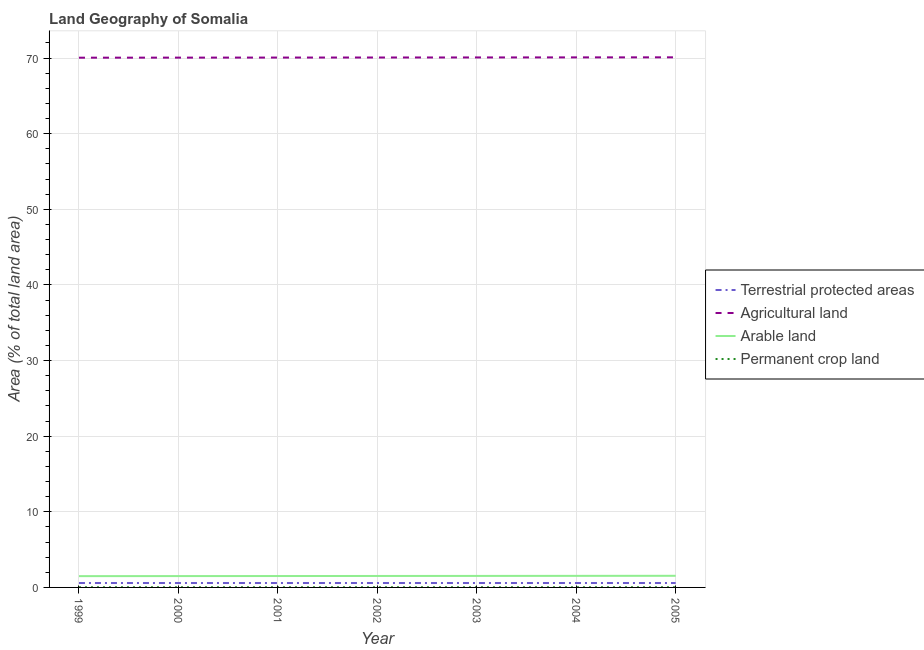Does the line corresponding to percentage of area under agricultural land intersect with the line corresponding to percentage of area under permanent crop land?
Your response must be concise. No. Is the number of lines equal to the number of legend labels?
Offer a terse response. Yes. What is the percentage of land under terrestrial protection in 2001?
Your response must be concise. 0.58. Across all years, what is the maximum percentage of area under permanent crop land?
Your answer should be compact. 0.02. Across all years, what is the minimum percentage of area under agricultural land?
Ensure brevity in your answer.  70.06. What is the total percentage of area under arable land in the graph?
Offer a very short reply. 10.61. What is the difference between the percentage of area under permanent crop land in 2001 and that in 2005?
Provide a short and direct response. -0. What is the difference between the percentage of area under agricultural land in 2002 and the percentage of land under terrestrial protection in 2003?
Provide a succinct answer. 69.5. What is the average percentage of area under permanent crop land per year?
Keep it short and to the point. 0.02. In the year 2005, what is the difference between the percentage of area under arable land and percentage of area under agricultural land?
Provide a succinct answer. -68.57. What is the ratio of the percentage of area under agricultural land in 2001 to that in 2005?
Ensure brevity in your answer.  1. Is the percentage of land under terrestrial protection in 1999 less than that in 2005?
Provide a short and direct response. No. What is the difference between the highest and the second highest percentage of area under agricultural land?
Your answer should be very brief. 0.01. What is the difference between the highest and the lowest percentage of land under terrestrial protection?
Your response must be concise. 3.1765633260461e-6. Is it the case that in every year, the sum of the percentage of area under arable land and percentage of area under permanent crop land is greater than the sum of percentage of land under terrestrial protection and percentage of area under agricultural land?
Your response must be concise. Yes. Is it the case that in every year, the sum of the percentage of land under terrestrial protection and percentage of area under agricultural land is greater than the percentage of area under arable land?
Provide a succinct answer. Yes. Does the percentage of area under arable land monotonically increase over the years?
Make the answer very short. Yes. Is the percentage of area under agricultural land strictly less than the percentage of area under permanent crop land over the years?
Ensure brevity in your answer.  No. How many years are there in the graph?
Provide a short and direct response. 7. What is the difference between two consecutive major ticks on the Y-axis?
Provide a short and direct response. 10. Are the values on the major ticks of Y-axis written in scientific E-notation?
Give a very brief answer. No. Does the graph contain grids?
Your response must be concise. Yes. Where does the legend appear in the graph?
Offer a terse response. Center right. What is the title of the graph?
Make the answer very short. Land Geography of Somalia. What is the label or title of the X-axis?
Offer a very short reply. Year. What is the label or title of the Y-axis?
Offer a terse response. Area (% of total land area). What is the Area (% of total land area) of Terrestrial protected areas in 1999?
Provide a succinct answer. 0.58. What is the Area (% of total land area) of Agricultural land in 1999?
Your answer should be very brief. 70.06. What is the Area (% of total land area) of Arable land in 1999?
Offer a very short reply. 1.49. What is the Area (% of total land area) of Permanent crop land in 1999?
Ensure brevity in your answer.  0.02. What is the Area (% of total land area) in Terrestrial protected areas in 2000?
Provide a succinct answer. 0.58. What is the Area (% of total land area) in Agricultural land in 2000?
Your answer should be very brief. 70.07. What is the Area (% of total land area) in Arable land in 2000?
Offer a terse response. 1.5. What is the Area (% of total land area) of Permanent crop land in 2000?
Make the answer very short. 0.02. What is the Area (% of total land area) of Terrestrial protected areas in 2001?
Keep it short and to the point. 0.58. What is the Area (% of total land area) in Agricultural land in 2001?
Give a very brief answer. 70.07. What is the Area (% of total land area) in Arable land in 2001?
Your answer should be very brief. 1.51. What is the Area (% of total land area) in Permanent crop land in 2001?
Give a very brief answer. 0.02. What is the Area (% of total land area) in Terrestrial protected areas in 2002?
Offer a very short reply. 0.58. What is the Area (% of total land area) in Agricultural land in 2002?
Your answer should be compact. 70.08. What is the Area (% of total land area) in Arable land in 2002?
Ensure brevity in your answer.  1.52. What is the Area (% of total land area) in Permanent crop land in 2002?
Your answer should be compact. 0.02. What is the Area (% of total land area) of Terrestrial protected areas in 2003?
Offer a terse response. 0.58. What is the Area (% of total land area) in Agricultural land in 2003?
Ensure brevity in your answer.  70.09. What is the Area (% of total land area) in Arable land in 2003?
Your answer should be very brief. 1.52. What is the Area (% of total land area) of Permanent crop land in 2003?
Your answer should be very brief. 0.02. What is the Area (% of total land area) of Terrestrial protected areas in 2004?
Ensure brevity in your answer.  0.58. What is the Area (% of total land area) of Agricultural land in 2004?
Offer a very short reply. 70.1. What is the Area (% of total land area) in Arable land in 2004?
Offer a terse response. 1.53. What is the Area (% of total land area) in Permanent crop land in 2004?
Offer a terse response. 0.02. What is the Area (% of total land area) in Terrestrial protected areas in 2005?
Provide a short and direct response. 0.58. What is the Area (% of total land area) of Agricultural land in 2005?
Provide a succinct answer. 70.11. What is the Area (% of total land area) in Arable land in 2005?
Make the answer very short. 1.54. What is the Area (% of total land area) of Permanent crop land in 2005?
Offer a terse response. 0.02. Across all years, what is the maximum Area (% of total land area) in Terrestrial protected areas?
Provide a succinct answer. 0.58. Across all years, what is the maximum Area (% of total land area) in Agricultural land?
Provide a succinct answer. 70.11. Across all years, what is the maximum Area (% of total land area) in Arable land?
Provide a short and direct response. 1.54. Across all years, what is the maximum Area (% of total land area) in Permanent crop land?
Your response must be concise. 0.02. Across all years, what is the minimum Area (% of total land area) of Terrestrial protected areas?
Offer a very short reply. 0.58. Across all years, what is the minimum Area (% of total land area) of Agricultural land?
Offer a terse response. 70.06. Across all years, what is the minimum Area (% of total land area) of Arable land?
Give a very brief answer. 1.49. Across all years, what is the minimum Area (% of total land area) of Permanent crop land?
Offer a very short reply. 0.02. What is the total Area (% of total land area) of Terrestrial protected areas in the graph?
Your response must be concise. 4.09. What is the total Area (% of total land area) in Agricultural land in the graph?
Your answer should be compact. 490.57. What is the total Area (% of total land area) of Arable land in the graph?
Offer a terse response. 10.61. What is the total Area (% of total land area) in Permanent crop land in the graph?
Offer a terse response. 0.16. What is the difference between the Area (% of total land area) in Terrestrial protected areas in 1999 and that in 2000?
Your answer should be compact. -0. What is the difference between the Area (% of total land area) of Agricultural land in 1999 and that in 2000?
Provide a short and direct response. -0.01. What is the difference between the Area (% of total land area) of Arable land in 1999 and that in 2000?
Your answer should be compact. -0.01. What is the difference between the Area (% of total land area) of Terrestrial protected areas in 1999 and that in 2001?
Keep it short and to the point. 0. What is the difference between the Area (% of total land area) in Agricultural land in 1999 and that in 2001?
Make the answer very short. -0.02. What is the difference between the Area (% of total land area) in Arable land in 1999 and that in 2001?
Make the answer very short. -0.02. What is the difference between the Area (% of total land area) of Permanent crop land in 1999 and that in 2001?
Ensure brevity in your answer.  0. What is the difference between the Area (% of total land area) of Terrestrial protected areas in 1999 and that in 2002?
Make the answer very short. 0. What is the difference between the Area (% of total land area) in Agricultural land in 1999 and that in 2002?
Your answer should be very brief. -0.02. What is the difference between the Area (% of total land area) of Arable land in 1999 and that in 2002?
Your answer should be compact. -0.02. What is the difference between the Area (% of total land area) of Agricultural land in 1999 and that in 2003?
Keep it short and to the point. -0.03. What is the difference between the Area (% of total land area) of Arable land in 1999 and that in 2003?
Your answer should be very brief. -0.03. What is the difference between the Area (% of total land area) of Permanent crop land in 1999 and that in 2003?
Provide a short and direct response. -0. What is the difference between the Area (% of total land area) in Agricultural land in 1999 and that in 2004?
Provide a short and direct response. -0.04. What is the difference between the Area (% of total land area) in Arable land in 1999 and that in 2004?
Make the answer very short. -0.04. What is the difference between the Area (% of total land area) of Permanent crop land in 1999 and that in 2004?
Make the answer very short. -0. What is the difference between the Area (% of total land area) in Agricultural land in 1999 and that in 2005?
Offer a terse response. -0.05. What is the difference between the Area (% of total land area) of Arable land in 1999 and that in 2005?
Offer a very short reply. -0.05. What is the difference between the Area (% of total land area) of Permanent crop land in 1999 and that in 2005?
Ensure brevity in your answer.  -0. What is the difference between the Area (% of total land area) of Agricultural land in 2000 and that in 2001?
Offer a very short reply. -0.01. What is the difference between the Area (% of total land area) of Arable land in 2000 and that in 2001?
Make the answer very short. -0.01. What is the difference between the Area (% of total land area) of Permanent crop land in 2000 and that in 2001?
Offer a very short reply. 0. What is the difference between the Area (% of total land area) of Agricultural land in 2000 and that in 2002?
Keep it short and to the point. -0.02. What is the difference between the Area (% of total land area) of Arable land in 2000 and that in 2002?
Your response must be concise. -0.02. What is the difference between the Area (% of total land area) in Permanent crop land in 2000 and that in 2002?
Keep it short and to the point. 0. What is the difference between the Area (% of total land area) in Agricultural land in 2000 and that in 2003?
Your answer should be very brief. -0.02. What is the difference between the Area (% of total land area) of Arable land in 2000 and that in 2003?
Provide a short and direct response. -0.02. What is the difference between the Area (% of total land area) in Permanent crop land in 2000 and that in 2003?
Provide a succinct answer. -0. What is the difference between the Area (% of total land area) of Agricultural land in 2000 and that in 2004?
Offer a terse response. -0.03. What is the difference between the Area (% of total land area) in Arable land in 2000 and that in 2004?
Keep it short and to the point. -0.03. What is the difference between the Area (% of total land area) of Permanent crop land in 2000 and that in 2004?
Provide a short and direct response. -0. What is the difference between the Area (% of total land area) of Agricultural land in 2000 and that in 2005?
Your response must be concise. -0.04. What is the difference between the Area (% of total land area) of Arable land in 2000 and that in 2005?
Your answer should be compact. -0.04. What is the difference between the Area (% of total land area) of Permanent crop land in 2000 and that in 2005?
Offer a very short reply. -0. What is the difference between the Area (% of total land area) of Agricultural land in 2001 and that in 2002?
Your answer should be very brief. -0.01. What is the difference between the Area (% of total land area) of Arable land in 2001 and that in 2002?
Offer a very short reply. -0.01. What is the difference between the Area (% of total land area) in Permanent crop land in 2001 and that in 2002?
Keep it short and to the point. 0. What is the difference between the Area (% of total land area) in Agricultural land in 2001 and that in 2003?
Provide a succinct answer. -0.02. What is the difference between the Area (% of total land area) in Arable land in 2001 and that in 2003?
Your answer should be compact. -0.01. What is the difference between the Area (% of total land area) in Permanent crop land in 2001 and that in 2003?
Offer a very short reply. -0. What is the difference between the Area (% of total land area) of Agricultural land in 2001 and that in 2004?
Make the answer very short. -0.02. What is the difference between the Area (% of total land area) of Arable land in 2001 and that in 2004?
Your answer should be very brief. -0.02. What is the difference between the Area (% of total land area) in Permanent crop land in 2001 and that in 2004?
Your response must be concise. -0. What is the difference between the Area (% of total land area) of Agricultural land in 2001 and that in 2005?
Your answer should be compact. -0.03. What is the difference between the Area (% of total land area) of Arable land in 2001 and that in 2005?
Give a very brief answer. -0.03. What is the difference between the Area (% of total land area) of Permanent crop land in 2001 and that in 2005?
Your answer should be compact. -0. What is the difference between the Area (% of total land area) in Agricultural land in 2002 and that in 2003?
Offer a terse response. -0.01. What is the difference between the Area (% of total land area) of Arable land in 2002 and that in 2003?
Your answer should be very brief. -0.01. What is the difference between the Area (% of total land area) in Permanent crop land in 2002 and that in 2003?
Your answer should be compact. -0. What is the difference between the Area (% of total land area) of Agricultural land in 2002 and that in 2004?
Your answer should be very brief. -0.02. What is the difference between the Area (% of total land area) in Arable land in 2002 and that in 2004?
Your response must be concise. -0.01. What is the difference between the Area (% of total land area) of Permanent crop land in 2002 and that in 2004?
Your answer should be compact. -0. What is the difference between the Area (% of total land area) in Agricultural land in 2002 and that in 2005?
Offer a very short reply. -0.02. What is the difference between the Area (% of total land area) in Arable land in 2002 and that in 2005?
Offer a very short reply. -0.02. What is the difference between the Area (% of total land area) of Permanent crop land in 2002 and that in 2005?
Your answer should be compact. -0. What is the difference between the Area (% of total land area) in Terrestrial protected areas in 2003 and that in 2004?
Your response must be concise. 0. What is the difference between the Area (% of total land area) of Agricultural land in 2003 and that in 2004?
Offer a very short reply. -0.01. What is the difference between the Area (% of total land area) in Arable land in 2003 and that in 2004?
Give a very brief answer. -0.01. What is the difference between the Area (% of total land area) in Terrestrial protected areas in 2003 and that in 2005?
Your answer should be compact. 0. What is the difference between the Area (% of total land area) of Agricultural land in 2003 and that in 2005?
Your response must be concise. -0.02. What is the difference between the Area (% of total land area) of Arable land in 2003 and that in 2005?
Provide a succinct answer. -0.02. What is the difference between the Area (% of total land area) in Terrestrial protected areas in 2004 and that in 2005?
Offer a very short reply. 0. What is the difference between the Area (% of total land area) of Agricultural land in 2004 and that in 2005?
Keep it short and to the point. -0.01. What is the difference between the Area (% of total land area) in Arable land in 2004 and that in 2005?
Provide a short and direct response. -0.01. What is the difference between the Area (% of total land area) in Terrestrial protected areas in 1999 and the Area (% of total land area) in Agricultural land in 2000?
Provide a succinct answer. -69.48. What is the difference between the Area (% of total land area) of Terrestrial protected areas in 1999 and the Area (% of total land area) of Arable land in 2000?
Offer a terse response. -0.92. What is the difference between the Area (% of total land area) in Terrestrial protected areas in 1999 and the Area (% of total land area) in Permanent crop land in 2000?
Offer a terse response. 0.56. What is the difference between the Area (% of total land area) in Agricultural land in 1999 and the Area (% of total land area) in Arable land in 2000?
Keep it short and to the point. 68.56. What is the difference between the Area (% of total land area) in Agricultural land in 1999 and the Area (% of total land area) in Permanent crop land in 2000?
Offer a very short reply. 70.04. What is the difference between the Area (% of total land area) in Arable land in 1999 and the Area (% of total land area) in Permanent crop land in 2000?
Offer a terse response. 1.47. What is the difference between the Area (% of total land area) in Terrestrial protected areas in 1999 and the Area (% of total land area) in Agricultural land in 2001?
Provide a succinct answer. -69.49. What is the difference between the Area (% of total land area) in Terrestrial protected areas in 1999 and the Area (% of total land area) in Arable land in 2001?
Ensure brevity in your answer.  -0.92. What is the difference between the Area (% of total land area) of Terrestrial protected areas in 1999 and the Area (% of total land area) of Permanent crop land in 2001?
Make the answer very short. 0.56. What is the difference between the Area (% of total land area) in Agricultural land in 1999 and the Area (% of total land area) in Arable land in 2001?
Provide a succinct answer. 68.55. What is the difference between the Area (% of total land area) in Agricultural land in 1999 and the Area (% of total land area) in Permanent crop land in 2001?
Provide a succinct answer. 70.04. What is the difference between the Area (% of total land area) in Arable land in 1999 and the Area (% of total land area) in Permanent crop land in 2001?
Give a very brief answer. 1.47. What is the difference between the Area (% of total land area) of Terrestrial protected areas in 1999 and the Area (% of total land area) of Agricultural land in 2002?
Ensure brevity in your answer.  -69.5. What is the difference between the Area (% of total land area) in Terrestrial protected areas in 1999 and the Area (% of total land area) in Arable land in 2002?
Ensure brevity in your answer.  -0.93. What is the difference between the Area (% of total land area) in Terrestrial protected areas in 1999 and the Area (% of total land area) in Permanent crop land in 2002?
Keep it short and to the point. 0.56. What is the difference between the Area (% of total land area) of Agricultural land in 1999 and the Area (% of total land area) of Arable land in 2002?
Keep it short and to the point. 68.54. What is the difference between the Area (% of total land area) in Agricultural land in 1999 and the Area (% of total land area) in Permanent crop land in 2002?
Offer a very short reply. 70.04. What is the difference between the Area (% of total land area) in Arable land in 1999 and the Area (% of total land area) in Permanent crop land in 2002?
Ensure brevity in your answer.  1.47. What is the difference between the Area (% of total land area) in Terrestrial protected areas in 1999 and the Area (% of total land area) in Agricultural land in 2003?
Offer a very short reply. -69.51. What is the difference between the Area (% of total land area) of Terrestrial protected areas in 1999 and the Area (% of total land area) of Arable land in 2003?
Offer a very short reply. -0.94. What is the difference between the Area (% of total land area) of Terrestrial protected areas in 1999 and the Area (% of total land area) of Permanent crop land in 2003?
Offer a terse response. 0.56. What is the difference between the Area (% of total land area) of Agricultural land in 1999 and the Area (% of total land area) of Arable land in 2003?
Your answer should be very brief. 68.54. What is the difference between the Area (% of total land area) in Agricultural land in 1999 and the Area (% of total land area) in Permanent crop land in 2003?
Your response must be concise. 70.03. What is the difference between the Area (% of total land area) of Arable land in 1999 and the Area (% of total land area) of Permanent crop land in 2003?
Give a very brief answer. 1.47. What is the difference between the Area (% of total land area) of Terrestrial protected areas in 1999 and the Area (% of total land area) of Agricultural land in 2004?
Your answer should be very brief. -69.51. What is the difference between the Area (% of total land area) of Terrestrial protected areas in 1999 and the Area (% of total land area) of Arable land in 2004?
Your answer should be very brief. -0.95. What is the difference between the Area (% of total land area) in Terrestrial protected areas in 1999 and the Area (% of total land area) in Permanent crop land in 2004?
Your answer should be compact. 0.56. What is the difference between the Area (% of total land area) in Agricultural land in 1999 and the Area (% of total land area) in Arable land in 2004?
Provide a short and direct response. 68.53. What is the difference between the Area (% of total land area) of Agricultural land in 1999 and the Area (% of total land area) of Permanent crop land in 2004?
Make the answer very short. 70.03. What is the difference between the Area (% of total land area) of Arable land in 1999 and the Area (% of total land area) of Permanent crop land in 2004?
Your answer should be compact. 1.47. What is the difference between the Area (% of total land area) in Terrestrial protected areas in 1999 and the Area (% of total land area) in Agricultural land in 2005?
Offer a terse response. -69.52. What is the difference between the Area (% of total land area) of Terrestrial protected areas in 1999 and the Area (% of total land area) of Arable land in 2005?
Offer a terse response. -0.95. What is the difference between the Area (% of total land area) of Terrestrial protected areas in 1999 and the Area (% of total land area) of Permanent crop land in 2005?
Your answer should be compact. 0.56. What is the difference between the Area (% of total land area) of Agricultural land in 1999 and the Area (% of total land area) of Arable land in 2005?
Make the answer very short. 68.52. What is the difference between the Area (% of total land area) of Agricultural land in 1999 and the Area (% of total land area) of Permanent crop land in 2005?
Ensure brevity in your answer.  70.03. What is the difference between the Area (% of total land area) of Arable land in 1999 and the Area (% of total land area) of Permanent crop land in 2005?
Provide a succinct answer. 1.47. What is the difference between the Area (% of total land area) in Terrestrial protected areas in 2000 and the Area (% of total land area) in Agricultural land in 2001?
Give a very brief answer. -69.49. What is the difference between the Area (% of total land area) in Terrestrial protected areas in 2000 and the Area (% of total land area) in Arable land in 2001?
Ensure brevity in your answer.  -0.92. What is the difference between the Area (% of total land area) of Terrestrial protected areas in 2000 and the Area (% of total land area) of Permanent crop land in 2001?
Keep it short and to the point. 0.56. What is the difference between the Area (% of total land area) in Agricultural land in 2000 and the Area (% of total land area) in Arable land in 2001?
Provide a short and direct response. 68.56. What is the difference between the Area (% of total land area) in Agricultural land in 2000 and the Area (% of total land area) in Permanent crop land in 2001?
Your response must be concise. 70.04. What is the difference between the Area (% of total land area) of Arable land in 2000 and the Area (% of total land area) of Permanent crop land in 2001?
Make the answer very short. 1.48. What is the difference between the Area (% of total land area) in Terrestrial protected areas in 2000 and the Area (% of total land area) in Agricultural land in 2002?
Your answer should be compact. -69.5. What is the difference between the Area (% of total land area) of Terrestrial protected areas in 2000 and the Area (% of total land area) of Arable land in 2002?
Offer a very short reply. -0.93. What is the difference between the Area (% of total land area) of Terrestrial protected areas in 2000 and the Area (% of total land area) of Permanent crop land in 2002?
Make the answer very short. 0.56. What is the difference between the Area (% of total land area) of Agricultural land in 2000 and the Area (% of total land area) of Arable land in 2002?
Offer a very short reply. 68.55. What is the difference between the Area (% of total land area) of Agricultural land in 2000 and the Area (% of total land area) of Permanent crop land in 2002?
Your answer should be very brief. 70.04. What is the difference between the Area (% of total land area) of Arable land in 2000 and the Area (% of total land area) of Permanent crop land in 2002?
Give a very brief answer. 1.48. What is the difference between the Area (% of total land area) in Terrestrial protected areas in 2000 and the Area (% of total land area) in Agricultural land in 2003?
Your answer should be very brief. -69.51. What is the difference between the Area (% of total land area) of Terrestrial protected areas in 2000 and the Area (% of total land area) of Arable land in 2003?
Ensure brevity in your answer.  -0.94. What is the difference between the Area (% of total land area) of Terrestrial protected areas in 2000 and the Area (% of total land area) of Permanent crop land in 2003?
Keep it short and to the point. 0.56. What is the difference between the Area (% of total land area) of Agricultural land in 2000 and the Area (% of total land area) of Arable land in 2003?
Provide a short and direct response. 68.54. What is the difference between the Area (% of total land area) in Agricultural land in 2000 and the Area (% of total land area) in Permanent crop land in 2003?
Your response must be concise. 70.04. What is the difference between the Area (% of total land area) in Arable land in 2000 and the Area (% of total land area) in Permanent crop land in 2003?
Offer a very short reply. 1.48. What is the difference between the Area (% of total land area) of Terrestrial protected areas in 2000 and the Area (% of total land area) of Agricultural land in 2004?
Offer a terse response. -69.51. What is the difference between the Area (% of total land area) of Terrestrial protected areas in 2000 and the Area (% of total land area) of Arable land in 2004?
Ensure brevity in your answer.  -0.95. What is the difference between the Area (% of total land area) in Terrestrial protected areas in 2000 and the Area (% of total land area) in Permanent crop land in 2004?
Keep it short and to the point. 0.56. What is the difference between the Area (% of total land area) of Agricultural land in 2000 and the Area (% of total land area) of Arable land in 2004?
Your answer should be very brief. 68.54. What is the difference between the Area (% of total land area) in Agricultural land in 2000 and the Area (% of total land area) in Permanent crop land in 2004?
Provide a succinct answer. 70.04. What is the difference between the Area (% of total land area) of Arable land in 2000 and the Area (% of total land area) of Permanent crop land in 2004?
Your answer should be compact. 1.48. What is the difference between the Area (% of total land area) in Terrestrial protected areas in 2000 and the Area (% of total land area) in Agricultural land in 2005?
Your answer should be very brief. -69.52. What is the difference between the Area (% of total land area) of Terrestrial protected areas in 2000 and the Area (% of total land area) of Arable land in 2005?
Offer a very short reply. -0.95. What is the difference between the Area (% of total land area) in Terrestrial protected areas in 2000 and the Area (% of total land area) in Permanent crop land in 2005?
Offer a terse response. 0.56. What is the difference between the Area (% of total land area) of Agricultural land in 2000 and the Area (% of total land area) of Arable land in 2005?
Offer a terse response. 68.53. What is the difference between the Area (% of total land area) in Agricultural land in 2000 and the Area (% of total land area) in Permanent crop land in 2005?
Provide a succinct answer. 70.04. What is the difference between the Area (% of total land area) of Arable land in 2000 and the Area (% of total land area) of Permanent crop land in 2005?
Ensure brevity in your answer.  1.48. What is the difference between the Area (% of total land area) of Terrestrial protected areas in 2001 and the Area (% of total land area) of Agricultural land in 2002?
Ensure brevity in your answer.  -69.5. What is the difference between the Area (% of total land area) in Terrestrial protected areas in 2001 and the Area (% of total land area) in Arable land in 2002?
Your response must be concise. -0.93. What is the difference between the Area (% of total land area) of Terrestrial protected areas in 2001 and the Area (% of total land area) of Permanent crop land in 2002?
Keep it short and to the point. 0.56. What is the difference between the Area (% of total land area) in Agricultural land in 2001 and the Area (% of total land area) in Arable land in 2002?
Provide a short and direct response. 68.56. What is the difference between the Area (% of total land area) in Agricultural land in 2001 and the Area (% of total land area) in Permanent crop land in 2002?
Provide a short and direct response. 70.05. What is the difference between the Area (% of total land area) of Arable land in 2001 and the Area (% of total land area) of Permanent crop land in 2002?
Offer a terse response. 1.49. What is the difference between the Area (% of total land area) of Terrestrial protected areas in 2001 and the Area (% of total land area) of Agricultural land in 2003?
Provide a short and direct response. -69.51. What is the difference between the Area (% of total land area) in Terrestrial protected areas in 2001 and the Area (% of total land area) in Arable land in 2003?
Ensure brevity in your answer.  -0.94. What is the difference between the Area (% of total land area) of Terrestrial protected areas in 2001 and the Area (% of total land area) of Permanent crop land in 2003?
Keep it short and to the point. 0.56. What is the difference between the Area (% of total land area) of Agricultural land in 2001 and the Area (% of total land area) of Arable land in 2003?
Offer a very short reply. 68.55. What is the difference between the Area (% of total land area) in Agricultural land in 2001 and the Area (% of total land area) in Permanent crop land in 2003?
Offer a very short reply. 70.05. What is the difference between the Area (% of total land area) in Arable land in 2001 and the Area (% of total land area) in Permanent crop land in 2003?
Offer a terse response. 1.48. What is the difference between the Area (% of total land area) of Terrestrial protected areas in 2001 and the Area (% of total land area) of Agricultural land in 2004?
Give a very brief answer. -69.51. What is the difference between the Area (% of total land area) of Terrestrial protected areas in 2001 and the Area (% of total land area) of Arable land in 2004?
Offer a terse response. -0.95. What is the difference between the Area (% of total land area) of Terrestrial protected areas in 2001 and the Area (% of total land area) of Permanent crop land in 2004?
Provide a succinct answer. 0.56. What is the difference between the Area (% of total land area) of Agricultural land in 2001 and the Area (% of total land area) of Arable land in 2004?
Your answer should be very brief. 68.54. What is the difference between the Area (% of total land area) in Agricultural land in 2001 and the Area (% of total land area) in Permanent crop land in 2004?
Your answer should be compact. 70.05. What is the difference between the Area (% of total land area) of Arable land in 2001 and the Area (% of total land area) of Permanent crop land in 2004?
Your answer should be very brief. 1.48. What is the difference between the Area (% of total land area) in Terrestrial protected areas in 2001 and the Area (% of total land area) in Agricultural land in 2005?
Provide a succinct answer. -69.52. What is the difference between the Area (% of total land area) in Terrestrial protected areas in 2001 and the Area (% of total land area) in Arable land in 2005?
Give a very brief answer. -0.95. What is the difference between the Area (% of total land area) in Terrestrial protected areas in 2001 and the Area (% of total land area) in Permanent crop land in 2005?
Ensure brevity in your answer.  0.56. What is the difference between the Area (% of total land area) of Agricultural land in 2001 and the Area (% of total land area) of Arable land in 2005?
Keep it short and to the point. 68.54. What is the difference between the Area (% of total land area) in Agricultural land in 2001 and the Area (% of total land area) in Permanent crop land in 2005?
Your answer should be compact. 70.05. What is the difference between the Area (% of total land area) of Arable land in 2001 and the Area (% of total land area) of Permanent crop land in 2005?
Your answer should be compact. 1.48. What is the difference between the Area (% of total land area) of Terrestrial protected areas in 2002 and the Area (% of total land area) of Agricultural land in 2003?
Provide a short and direct response. -69.51. What is the difference between the Area (% of total land area) of Terrestrial protected areas in 2002 and the Area (% of total land area) of Arable land in 2003?
Ensure brevity in your answer.  -0.94. What is the difference between the Area (% of total land area) of Terrestrial protected areas in 2002 and the Area (% of total land area) of Permanent crop land in 2003?
Make the answer very short. 0.56. What is the difference between the Area (% of total land area) in Agricultural land in 2002 and the Area (% of total land area) in Arable land in 2003?
Ensure brevity in your answer.  68.56. What is the difference between the Area (% of total land area) of Agricultural land in 2002 and the Area (% of total land area) of Permanent crop land in 2003?
Provide a short and direct response. 70.06. What is the difference between the Area (% of total land area) of Arable land in 2002 and the Area (% of total land area) of Permanent crop land in 2003?
Offer a very short reply. 1.49. What is the difference between the Area (% of total land area) in Terrestrial protected areas in 2002 and the Area (% of total land area) in Agricultural land in 2004?
Ensure brevity in your answer.  -69.51. What is the difference between the Area (% of total land area) in Terrestrial protected areas in 2002 and the Area (% of total land area) in Arable land in 2004?
Keep it short and to the point. -0.95. What is the difference between the Area (% of total land area) of Terrestrial protected areas in 2002 and the Area (% of total land area) of Permanent crop land in 2004?
Offer a very short reply. 0.56. What is the difference between the Area (% of total land area) of Agricultural land in 2002 and the Area (% of total land area) of Arable land in 2004?
Your response must be concise. 68.55. What is the difference between the Area (% of total land area) in Agricultural land in 2002 and the Area (% of total land area) in Permanent crop land in 2004?
Make the answer very short. 70.06. What is the difference between the Area (% of total land area) in Arable land in 2002 and the Area (% of total land area) in Permanent crop land in 2004?
Keep it short and to the point. 1.49. What is the difference between the Area (% of total land area) of Terrestrial protected areas in 2002 and the Area (% of total land area) of Agricultural land in 2005?
Provide a short and direct response. -69.52. What is the difference between the Area (% of total land area) in Terrestrial protected areas in 2002 and the Area (% of total land area) in Arable land in 2005?
Provide a succinct answer. -0.95. What is the difference between the Area (% of total land area) of Terrestrial protected areas in 2002 and the Area (% of total land area) of Permanent crop land in 2005?
Provide a succinct answer. 0.56. What is the difference between the Area (% of total land area) in Agricultural land in 2002 and the Area (% of total land area) in Arable land in 2005?
Give a very brief answer. 68.54. What is the difference between the Area (% of total land area) in Agricultural land in 2002 and the Area (% of total land area) in Permanent crop land in 2005?
Your answer should be very brief. 70.06. What is the difference between the Area (% of total land area) of Arable land in 2002 and the Area (% of total land area) of Permanent crop land in 2005?
Offer a very short reply. 1.49. What is the difference between the Area (% of total land area) of Terrestrial protected areas in 2003 and the Area (% of total land area) of Agricultural land in 2004?
Give a very brief answer. -69.51. What is the difference between the Area (% of total land area) in Terrestrial protected areas in 2003 and the Area (% of total land area) in Arable land in 2004?
Provide a succinct answer. -0.95. What is the difference between the Area (% of total land area) of Terrestrial protected areas in 2003 and the Area (% of total land area) of Permanent crop land in 2004?
Your response must be concise. 0.56. What is the difference between the Area (% of total land area) of Agricultural land in 2003 and the Area (% of total land area) of Arable land in 2004?
Your answer should be compact. 68.56. What is the difference between the Area (% of total land area) of Agricultural land in 2003 and the Area (% of total land area) of Permanent crop land in 2004?
Provide a succinct answer. 70.07. What is the difference between the Area (% of total land area) in Arable land in 2003 and the Area (% of total land area) in Permanent crop land in 2004?
Offer a very short reply. 1.5. What is the difference between the Area (% of total land area) in Terrestrial protected areas in 2003 and the Area (% of total land area) in Agricultural land in 2005?
Offer a terse response. -69.52. What is the difference between the Area (% of total land area) in Terrestrial protected areas in 2003 and the Area (% of total land area) in Arable land in 2005?
Offer a terse response. -0.95. What is the difference between the Area (% of total land area) of Terrestrial protected areas in 2003 and the Area (% of total land area) of Permanent crop land in 2005?
Your answer should be very brief. 0.56. What is the difference between the Area (% of total land area) in Agricultural land in 2003 and the Area (% of total land area) in Arable land in 2005?
Your answer should be compact. 68.55. What is the difference between the Area (% of total land area) of Agricultural land in 2003 and the Area (% of total land area) of Permanent crop land in 2005?
Ensure brevity in your answer.  70.07. What is the difference between the Area (% of total land area) in Arable land in 2003 and the Area (% of total land area) in Permanent crop land in 2005?
Your answer should be compact. 1.5. What is the difference between the Area (% of total land area) in Terrestrial protected areas in 2004 and the Area (% of total land area) in Agricultural land in 2005?
Give a very brief answer. -69.52. What is the difference between the Area (% of total land area) in Terrestrial protected areas in 2004 and the Area (% of total land area) in Arable land in 2005?
Your answer should be compact. -0.95. What is the difference between the Area (% of total land area) of Terrestrial protected areas in 2004 and the Area (% of total land area) of Permanent crop land in 2005?
Your answer should be very brief. 0.56. What is the difference between the Area (% of total land area) of Agricultural land in 2004 and the Area (% of total land area) of Arable land in 2005?
Offer a terse response. 68.56. What is the difference between the Area (% of total land area) in Agricultural land in 2004 and the Area (% of total land area) in Permanent crop land in 2005?
Offer a terse response. 70.07. What is the difference between the Area (% of total land area) in Arable land in 2004 and the Area (% of total land area) in Permanent crop land in 2005?
Ensure brevity in your answer.  1.51. What is the average Area (% of total land area) of Terrestrial protected areas per year?
Your answer should be very brief. 0.58. What is the average Area (% of total land area) in Agricultural land per year?
Your answer should be very brief. 70.08. What is the average Area (% of total land area) in Arable land per year?
Give a very brief answer. 1.52. What is the average Area (% of total land area) of Permanent crop land per year?
Offer a very short reply. 0.02. In the year 1999, what is the difference between the Area (% of total land area) in Terrestrial protected areas and Area (% of total land area) in Agricultural land?
Keep it short and to the point. -69.47. In the year 1999, what is the difference between the Area (% of total land area) of Terrestrial protected areas and Area (% of total land area) of Arable land?
Provide a succinct answer. -0.91. In the year 1999, what is the difference between the Area (% of total land area) in Terrestrial protected areas and Area (% of total land area) in Permanent crop land?
Provide a short and direct response. 0.56. In the year 1999, what is the difference between the Area (% of total land area) in Agricultural land and Area (% of total land area) in Arable land?
Make the answer very short. 68.57. In the year 1999, what is the difference between the Area (% of total land area) in Agricultural land and Area (% of total land area) in Permanent crop land?
Give a very brief answer. 70.04. In the year 1999, what is the difference between the Area (% of total land area) in Arable land and Area (% of total land area) in Permanent crop land?
Your response must be concise. 1.47. In the year 2000, what is the difference between the Area (% of total land area) in Terrestrial protected areas and Area (% of total land area) in Agricultural land?
Your answer should be very brief. -69.48. In the year 2000, what is the difference between the Area (% of total land area) of Terrestrial protected areas and Area (% of total land area) of Arable land?
Offer a terse response. -0.92. In the year 2000, what is the difference between the Area (% of total land area) in Terrestrial protected areas and Area (% of total land area) in Permanent crop land?
Your response must be concise. 0.56. In the year 2000, what is the difference between the Area (% of total land area) in Agricultural land and Area (% of total land area) in Arable land?
Keep it short and to the point. 68.57. In the year 2000, what is the difference between the Area (% of total land area) of Agricultural land and Area (% of total land area) of Permanent crop land?
Offer a very short reply. 70.04. In the year 2000, what is the difference between the Area (% of total land area) in Arable land and Area (% of total land area) in Permanent crop land?
Make the answer very short. 1.48. In the year 2001, what is the difference between the Area (% of total land area) of Terrestrial protected areas and Area (% of total land area) of Agricultural land?
Provide a succinct answer. -69.49. In the year 2001, what is the difference between the Area (% of total land area) in Terrestrial protected areas and Area (% of total land area) in Arable land?
Ensure brevity in your answer.  -0.92. In the year 2001, what is the difference between the Area (% of total land area) of Terrestrial protected areas and Area (% of total land area) of Permanent crop land?
Provide a succinct answer. 0.56. In the year 2001, what is the difference between the Area (% of total land area) in Agricultural land and Area (% of total land area) in Arable land?
Provide a short and direct response. 68.57. In the year 2001, what is the difference between the Area (% of total land area) in Agricultural land and Area (% of total land area) in Permanent crop land?
Provide a short and direct response. 70.05. In the year 2001, what is the difference between the Area (% of total land area) of Arable land and Area (% of total land area) of Permanent crop land?
Give a very brief answer. 1.49. In the year 2002, what is the difference between the Area (% of total land area) of Terrestrial protected areas and Area (% of total land area) of Agricultural land?
Ensure brevity in your answer.  -69.5. In the year 2002, what is the difference between the Area (% of total land area) of Terrestrial protected areas and Area (% of total land area) of Arable land?
Make the answer very short. -0.93. In the year 2002, what is the difference between the Area (% of total land area) of Terrestrial protected areas and Area (% of total land area) of Permanent crop land?
Give a very brief answer. 0.56. In the year 2002, what is the difference between the Area (% of total land area) in Agricultural land and Area (% of total land area) in Arable land?
Your answer should be compact. 68.57. In the year 2002, what is the difference between the Area (% of total land area) in Agricultural land and Area (% of total land area) in Permanent crop land?
Your response must be concise. 70.06. In the year 2002, what is the difference between the Area (% of total land area) of Arable land and Area (% of total land area) of Permanent crop land?
Your answer should be very brief. 1.49. In the year 2003, what is the difference between the Area (% of total land area) in Terrestrial protected areas and Area (% of total land area) in Agricultural land?
Your answer should be compact. -69.51. In the year 2003, what is the difference between the Area (% of total land area) in Terrestrial protected areas and Area (% of total land area) in Arable land?
Offer a very short reply. -0.94. In the year 2003, what is the difference between the Area (% of total land area) in Terrestrial protected areas and Area (% of total land area) in Permanent crop land?
Your answer should be compact. 0.56. In the year 2003, what is the difference between the Area (% of total land area) in Agricultural land and Area (% of total land area) in Arable land?
Offer a terse response. 68.57. In the year 2003, what is the difference between the Area (% of total land area) of Agricultural land and Area (% of total land area) of Permanent crop land?
Provide a short and direct response. 70.07. In the year 2003, what is the difference between the Area (% of total land area) of Arable land and Area (% of total land area) of Permanent crop land?
Your answer should be compact. 1.5. In the year 2004, what is the difference between the Area (% of total land area) in Terrestrial protected areas and Area (% of total land area) in Agricultural land?
Keep it short and to the point. -69.51. In the year 2004, what is the difference between the Area (% of total land area) in Terrestrial protected areas and Area (% of total land area) in Arable land?
Give a very brief answer. -0.95. In the year 2004, what is the difference between the Area (% of total land area) of Terrestrial protected areas and Area (% of total land area) of Permanent crop land?
Your answer should be compact. 0.56. In the year 2004, what is the difference between the Area (% of total land area) of Agricultural land and Area (% of total land area) of Arable land?
Keep it short and to the point. 68.57. In the year 2004, what is the difference between the Area (% of total land area) in Agricultural land and Area (% of total land area) in Permanent crop land?
Your answer should be very brief. 70.07. In the year 2004, what is the difference between the Area (% of total land area) of Arable land and Area (% of total land area) of Permanent crop land?
Offer a terse response. 1.51. In the year 2005, what is the difference between the Area (% of total land area) in Terrestrial protected areas and Area (% of total land area) in Agricultural land?
Your answer should be very brief. -69.52. In the year 2005, what is the difference between the Area (% of total land area) in Terrestrial protected areas and Area (% of total land area) in Arable land?
Keep it short and to the point. -0.95. In the year 2005, what is the difference between the Area (% of total land area) of Terrestrial protected areas and Area (% of total land area) of Permanent crop land?
Make the answer very short. 0.56. In the year 2005, what is the difference between the Area (% of total land area) in Agricultural land and Area (% of total land area) in Arable land?
Your answer should be compact. 68.57. In the year 2005, what is the difference between the Area (% of total land area) of Agricultural land and Area (% of total land area) of Permanent crop land?
Offer a terse response. 70.08. In the year 2005, what is the difference between the Area (% of total land area) in Arable land and Area (% of total land area) in Permanent crop land?
Provide a succinct answer. 1.51. What is the ratio of the Area (% of total land area) of Agricultural land in 1999 to that in 2000?
Ensure brevity in your answer.  1. What is the ratio of the Area (% of total land area) of Terrestrial protected areas in 1999 to that in 2001?
Make the answer very short. 1. What is the ratio of the Area (% of total land area) in Terrestrial protected areas in 1999 to that in 2002?
Keep it short and to the point. 1. What is the ratio of the Area (% of total land area) in Arable land in 1999 to that in 2002?
Offer a terse response. 0.98. What is the ratio of the Area (% of total land area) in Permanent crop land in 1999 to that in 2002?
Your answer should be compact. 1. What is the ratio of the Area (% of total land area) of Arable land in 1999 to that in 2003?
Offer a very short reply. 0.98. What is the ratio of the Area (% of total land area) of Permanent crop land in 1999 to that in 2003?
Provide a succinct answer. 0.93. What is the ratio of the Area (% of total land area) in Terrestrial protected areas in 1999 to that in 2004?
Provide a short and direct response. 1. What is the ratio of the Area (% of total land area) in Arable land in 1999 to that in 2004?
Ensure brevity in your answer.  0.97. What is the ratio of the Area (% of total land area) of Agricultural land in 1999 to that in 2005?
Provide a short and direct response. 1. What is the ratio of the Area (% of total land area) in Arable land in 1999 to that in 2005?
Your answer should be very brief. 0.97. What is the ratio of the Area (% of total land area) of Permanent crop land in 1999 to that in 2005?
Ensure brevity in your answer.  0.93. What is the ratio of the Area (% of total land area) in Arable land in 2000 to that in 2001?
Your response must be concise. 0.99. What is the ratio of the Area (% of total land area) of Permanent crop land in 2000 to that in 2001?
Make the answer very short. 1. What is the ratio of the Area (% of total land area) of Agricultural land in 2000 to that in 2002?
Make the answer very short. 1. What is the ratio of the Area (% of total land area) of Arable land in 2000 to that in 2002?
Provide a short and direct response. 0.99. What is the ratio of the Area (% of total land area) in Permanent crop land in 2000 to that in 2002?
Your answer should be compact. 1. What is the ratio of the Area (% of total land area) in Agricultural land in 2000 to that in 2003?
Ensure brevity in your answer.  1. What is the ratio of the Area (% of total land area) in Permanent crop land in 2000 to that in 2003?
Provide a succinct answer. 0.93. What is the ratio of the Area (% of total land area) in Terrestrial protected areas in 2000 to that in 2004?
Offer a very short reply. 1. What is the ratio of the Area (% of total land area) of Arable land in 2000 to that in 2004?
Your answer should be compact. 0.98. What is the ratio of the Area (% of total land area) of Terrestrial protected areas in 2000 to that in 2005?
Your response must be concise. 1. What is the ratio of the Area (% of total land area) in Arable land in 2000 to that in 2005?
Offer a terse response. 0.98. What is the ratio of the Area (% of total land area) in Permanent crop land in 2000 to that in 2005?
Your response must be concise. 0.93. What is the ratio of the Area (% of total land area) of Agricultural land in 2001 to that in 2002?
Your response must be concise. 1. What is the ratio of the Area (% of total land area) of Arable land in 2001 to that in 2002?
Provide a succinct answer. 0.99. What is the ratio of the Area (% of total land area) in Agricultural land in 2001 to that in 2003?
Your answer should be compact. 1. What is the ratio of the Area (% of total land area) of Arable land in 2001 to that in 2003?
Offer a terse response. 0.99. What is the ratio of the Area (% of total land area) of Permanent crop land in 2001 to that in 2003?
Provide a short and direct response. 0.93. What is the ratio of the Area (% of total land area) in Terrestrial protected areas in 2001 to that in 2004?
Provide a short and direct response. 1. What is the ratio of the Area (% of total land area) in Agricultural land in 2001 to that in 2004?
Provide a succinct answer. 1. What is the ratio of the Area (% of total land area) of Arable land in 2001 to that in 2004?
Make the answer very short. 0.99. What is the ratio of the Area (% of total land area) of Agricultural land in 2001 to that in 2005?
Your answer should be compact. 1. What is the ratio of the Area (% of total land area) of Arable land in 2001 to that in 2005?
Offer a very short reply. 0.98. What is the ratio of the Area (% of total land area) in Permanent crop land in 2001 to that in 2005?
Provide a succinct answer. 0.93. What is the ratio of the Area (% of total land area) of Terrestrial protected areas in 2002 to that in 2003?
Your response must be concise. 1. What is the ratio of the Area (% of total land area) in Agricultural land in 2002 to that in 2003?
Offer a terse response. 1. What is the ratio of the Area (% of total land area) of Terrestrial protected areas in 2002 to that in 2004?
Offer a very short reply. 1. What is the ratio of the Area (% of total land area) of Agricultural land in 2002 to that in 2004?
Provide a succinct answer. 1. What is the ratio of the Area (% of total land area) of Arable land in 2002 to that in 2004?
Keep it short and to the point. 0.99. What is the ratio of the Area (% of total land area) of Terrestrial protected areas in 2002 to that in 2005?
Offer a terse response. 1. What is the ratio of the Area (% of total land area) of Arable land in 2002 to that in 2005?
Offer a terse response. 0.99. What is the ratio of the Area (% of total land area) in Agricultural land in 2003 to that in 2004?
Make the answer very short. 1. What is the ratio of the Area (% of total land area) in Permanent crop land in 2003 to that in 2004?
Your response must be concise. 1. What is the ratio of the Area (% of total land area) of Agricultural land in 2003 to that in 2005?
Make the answer very short. 1. What is the ratio of the Area (% of total land area) in Agricultural land in 2004 to that in 2005?
Give a very brief answer. 1. What is the ratio of the Area (% of total land area) in Arable land in 2004 to that in 2005?
Your response must be concise. 0.99. What is the ratio of the Area (% of total land area) of Permanent crop land in 2004 to that in 2005?
Your response must be concise. 1. What is the difference between the highest and the second highest Area (% of total land area) in Terrestrial protected areas?
Ensure brevity in your answer.  0. What is the difference between the highest and the second highest Area (% of total land area) in Agricultural land?
Your response must be concise. 0.01. What is the difference between the highest and the second highest Area (% of total land area) of Arable land?
Offer a very short reply. 0.01. What is the difference between the highest and the second highest Area (% of total land area) of Permanent crop land?
Your answer should be compact. 0. What is the difference between the highest and the lowest Area (% of total land area) of Agricultural land?
Offer a terse response. 0.05. What is the difference between the highest and the lowest Area (% of total land area) of Arable land?
Keep it short and to the point. 0.05. What is the difference between the highest and the lowest Area (% of total land area) in Permanent crop land?
Ensure brevity in your answer.  0. 